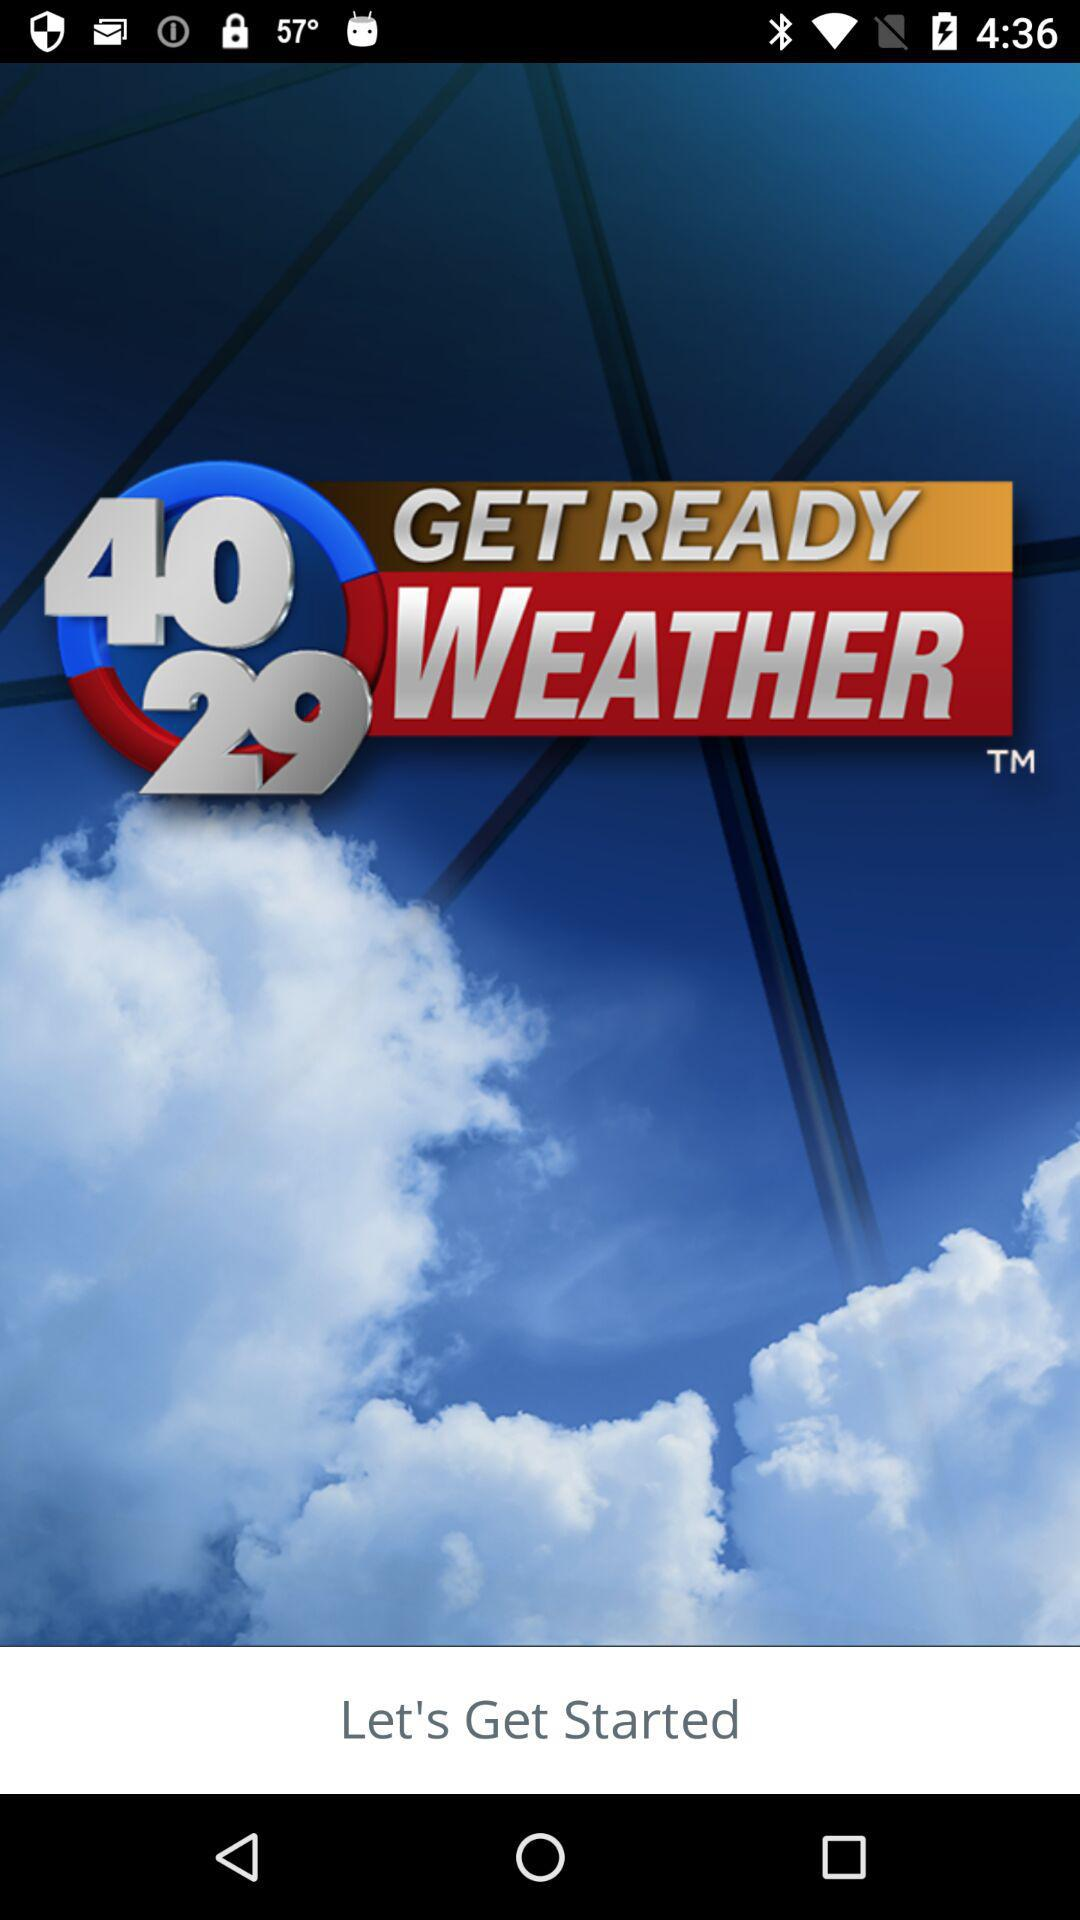What is the name of the application? The name of the application is "40 29 GET READY WEATHER". 